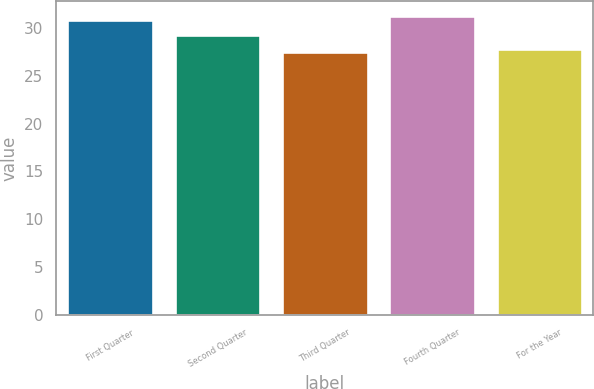<chart> <loc_0><loc_0><loc_500><loc_500><bar_chart><fcel>First Quarter<fcel>Second Quarter<fcel>Third Quarter<fcel>Fourth Quarter<fcel>For the Year<nl><fcel>30.87<fcel>29.3<fcel>27.49<fcel>31.21<fcel>27.83<nl></chart> 